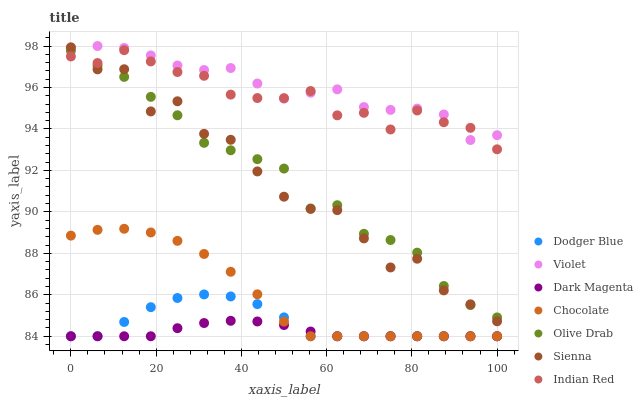Does Dark Magenta have the minimum area under the curve?
Answer yes or no. Yes. Does Violet have the maximum area under the curve?
Answer yes or no. Yes. Does Chocolate have the minimum area under the curve?
Answer yes or no. No. Does Chocolate have the maximum area under the curve?
Answer yes or no. No. Is Dark Magenta the smoothest?
Answer yes or no. Yes. Is Sienna the roughest?
Answer yes or no. Yes. Is Chocolate the smoothest?
Answer yes or no. No. Is Chocolate the roughest?
Answer yes or no. No. Does Dark Magenta have the lowest value?
Answer yes or no. Yes. Does Sienna have the lowest value?
Answer yes or no. No. Does Violet have the highest value?
Answer yes or no. Yes. Does Chocolate have the highest value?
Answer yes or no. No. Is Dodger Blue less than Indian Red?
Answer yes or no. Yes. Is Indian Red greater than Chocolate?
Answer yes or no. Yes. Does Dark Magenta intersect Dodger Blue?
Answer yes or no. Yes. Is Dark Magenta less than Dodger Blue?
Answer yes or no. No. Is Dark Magenta greater than Dodger Blue?
Answer yes or no. No. Does Dodger Blue intersect Indian Red?
Answer yes or no. No. 